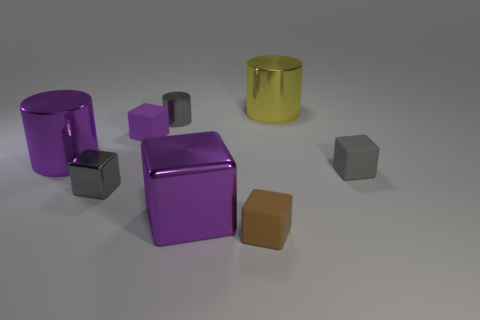Is the number of gray rubber objects less than the number of big cyan spheres?
Provide a short and direct response. No. There is a gray metallic object to the left of the small cylinder; does it have the same shape as the brown rubber thing?
Ensure brevity in your answer.  Yes. Are there any big gray cubes?
Provide a short and direct response. No. What color is the large cylinder that is in front of the large cylinder that is behind the purple object that is behind the purple metal cylinder?
Your response must be concise. Purple. Are there an equal number of tiny gray objects that are behind the gray cylinder and brown rubber cubes to the right of the purple rubber object?
Your answer should be very brief. No. What is the shape of the purple object that is the same size as the gray matte thing?
Ensure brevity in your answer.  Cube. Is there a object of the same color as the big cube?
Keep it short and to the point. Yes. There is a gray thing that is to the right of the big purple cube; what is its shape?
Your response must be concise. Cube. The large cube has what color?
Make the answer very short. Purple. There is another cube that is the same material as the large cube; what is its color?
Your answer should be very brief. Gray. 